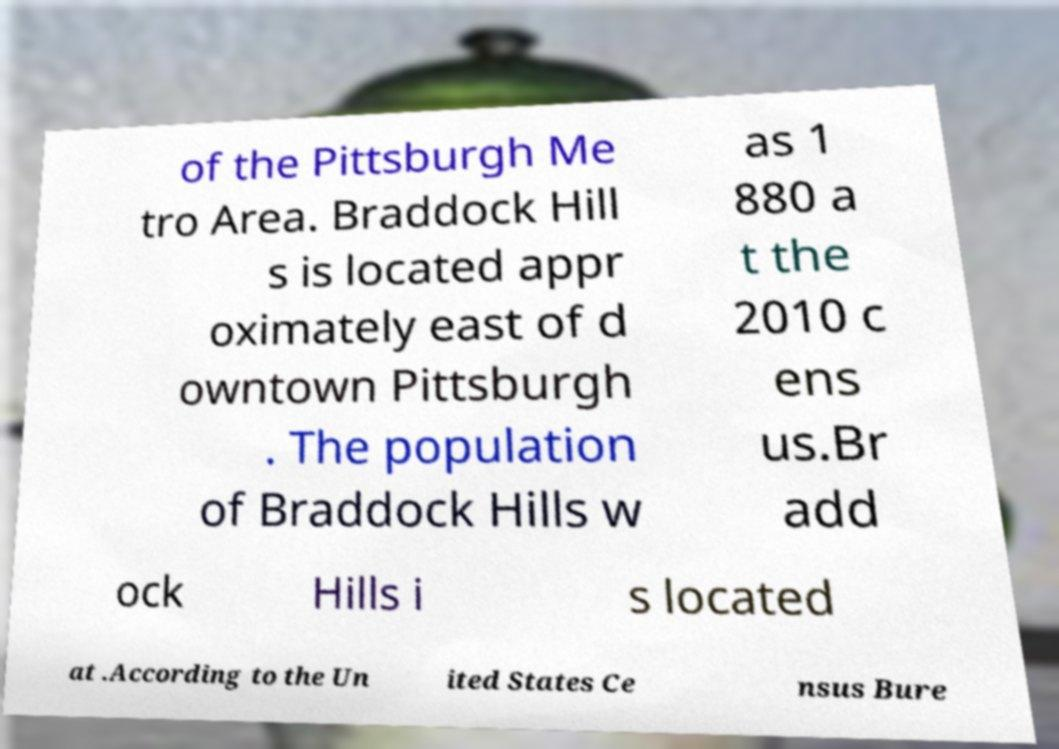There's text embedded in this image that I need extracted. Can you transcribe it verbatim? of the Pittsburgh Me tro Area. Braddock Hill s is located appr oximately east of d owntown Pittsburgh . The population of Braddock Hills w as 1 880 a t the 2010 c ens us.Br add ock Hills i s located at .According to the Un ited States Ce nsus Bure 